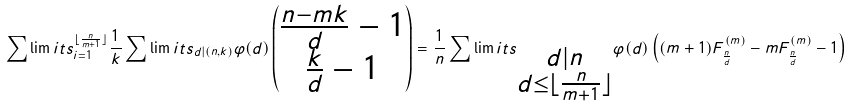Convert formula to latex. <formula><loc_0><loc_0><loc_500><loc_500>\sum \lim i t s ^ { \lfloor \frac { n } { m + 1 } \rfloor } _ { i = 1 } \frac { 1 } { k } \sum \lim i t s _ { d | ( n , k ) } \varphi ( d ) \begin{pmatrix} \frac { n - m k } { d } - 1 \\ \frac { k } { d } - 1 \end{pmatrix} = \frac { 1 } { n } \sum \lim i t s _ { \substack { d | n \\ d \leq \lfloor \frac { n } { m + 1 } \rfloor } } \varphi ( d ) \left ( ( m + 1 ) F ^ { ( m ) } _ { \frac { n } { d } } - m F ^ { ( m ) } _ { \frac { n } { d } } - 1 \right )</formula> 